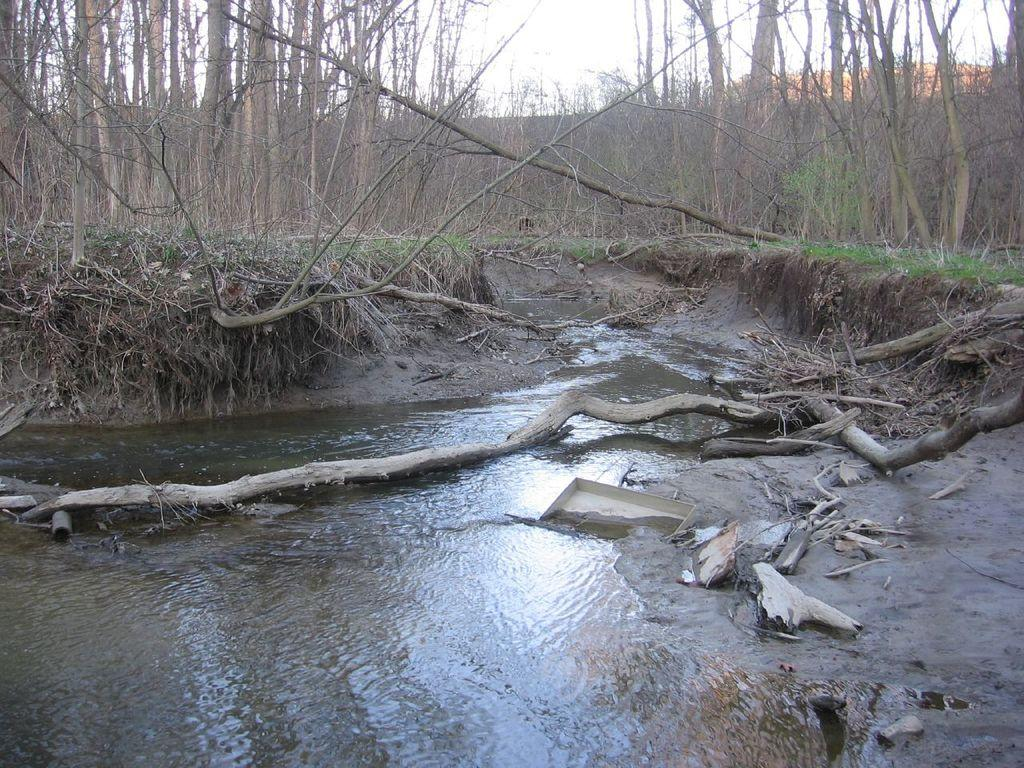What is the primary element visible in the image? There is water in the image. What type of vegetation can be seen in the image? There are trees in the image. What material is present in the image? Wood is present in the image. What is the surface visible in the image? The ground is visible in the image. What type of landscape feature can be seen in the image? There are hills in the image. What part of the natural environment is visible in the image? The sky is visible in the image. What type of orange can be seen growing on the trees in the image? There are no oranges present in the image; it features trees without any visible fruit. What type of act is being performed by the trees in the image? Trees do not perform acts; they are stationary plants in the image. 